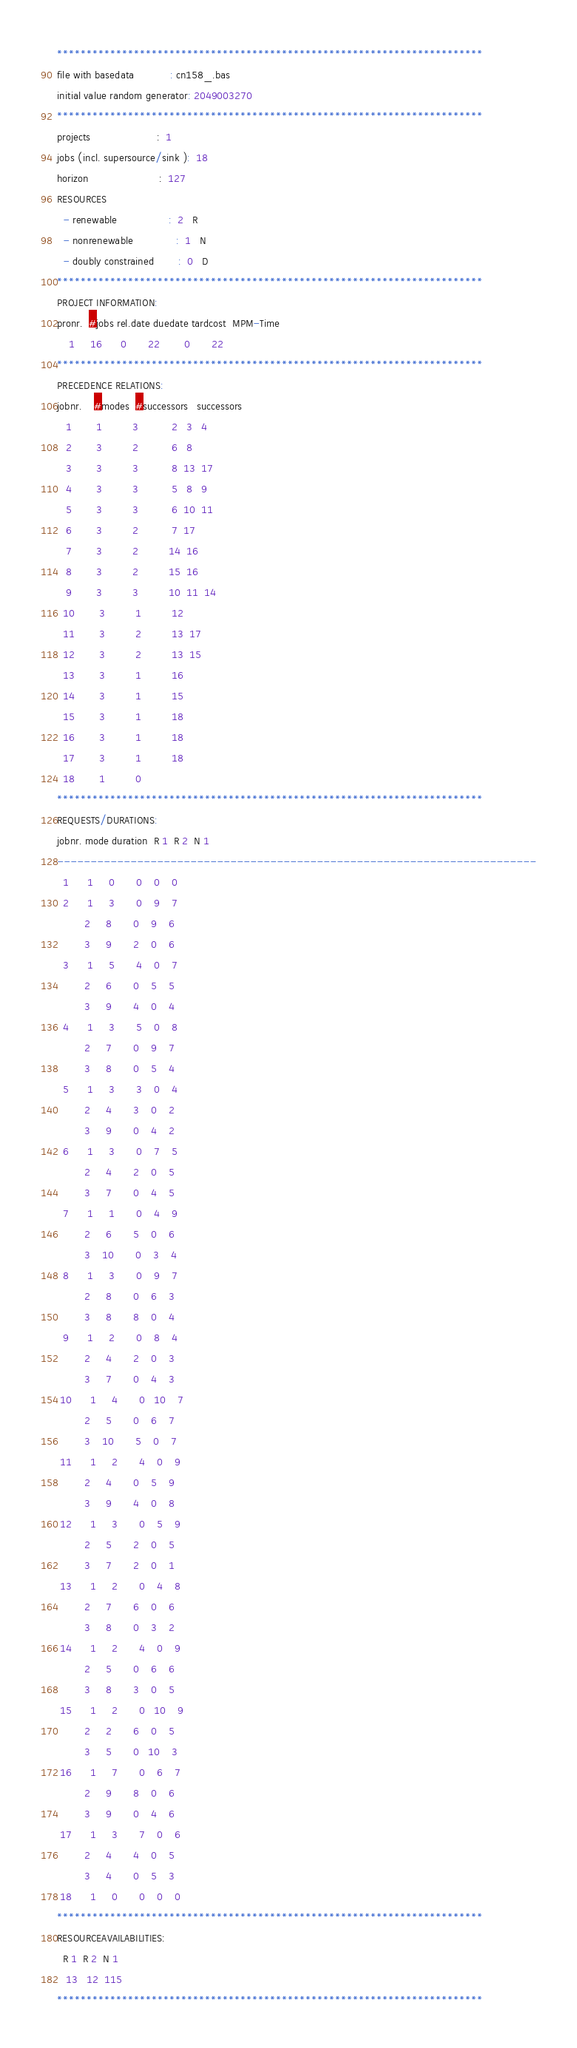Convert code to text. <code><loc_0><loc_0><loc_500><loc_500><_ObjectiveC_>************************************************************************
file with basedata            : cn158_.bas
initial value random generator: 2049003270
************************************************************************
projects                      :  1
jobs (incl. supersource/sink ):  18
horizon                       :  127
RESOURCES
  - renewable                 :  2   R
  - nonrenewable              :  1   N
  - doubly constrained        :  0   D
************************************************************************
PROJECT INFORMATION:
pronr.  #jobs rel.date duedate tardcost  MPM-Time
    1     16      0       22        0       22
************************************************************************
PRECEDENCE RELATIONS:
jobnr.    #modes  #successors   successors
   1        1          3           2   3   4
   2        3          2           6   8
   3        3          3           8  13  17
   4        3          3           5   8   9
   5        3          3           6  10  11
   6        3          2           7  17
   7        3          2          14  16
   8        3          2          15  16
   9        3          3          10  11  14
  10        3          1          12
  11        3          2          13  17
  12        3          2          13  15
  13        3          1          16
  14        3          1          15
  15        3          1          18
  16        3          1          18
  17        3          1          18
  18        1          0        
************************************************************************
REQUESTS/DURATIONS:
jobnr. mode duration  R 1  R 2  N 1
------------------------------------------------------------------------
  1      1     0       0    0    0
  2      1     3       0    9    7
         2     8       0    9    6
         3     9       2    0    6
  3      1     5       4    0    7
         2     6       0    5    5
         3     9       4    0    4
  4      1     3       5    0    8
         2     7       0    9    7
         3     8       0    5    4
  5      1     3       3    0    4
         2     4       3    0    2
         3     9       0    4    2
  6      1     3       0    7    5
         2     4       2    0    5
         3     7       0    4    5
  7      1     1       0    4    9
         2     6       5    0    6
         3    10       0    3    4
  8      1     3       0    9    7
         2     8       0    6    3
         3     8       8    0    4
  9      1     2       0    8    4
         2     4       2    0    3
         3     7       0    4    3
 10      1     4       0   10    7
         2     5       0    6    7
         3    10       5    0    7
 11      1     2       4    0    9
         2     4       0    5    9
         3     9       4    0    8
 12      1     3       0    5    9
         2     5       2    0    5
         3     7       2    0    1
 13      1     2       0    4    8
         2     7       6    0    6
         3     8       0    3    2
 14      1     2       4    0    9
         2     5       0    6    6
         3     8       3    0    5
 15      1     2       0   10    9
         2     2       6    0    5
         3     5       0   10    3
 16      1     7       0    6    7
         2     9       8    0    6
         3     9       0    4    6
 17      1     3       7    0    6
         2     4       4    0    5
         3     4       0    5    3
 18      1     0       0    0    0
************************************************************************
RESOURCEAVAILABILITIES:
  R 1  R 2  N 1
   13   12  115
************************************************************************
</code> 